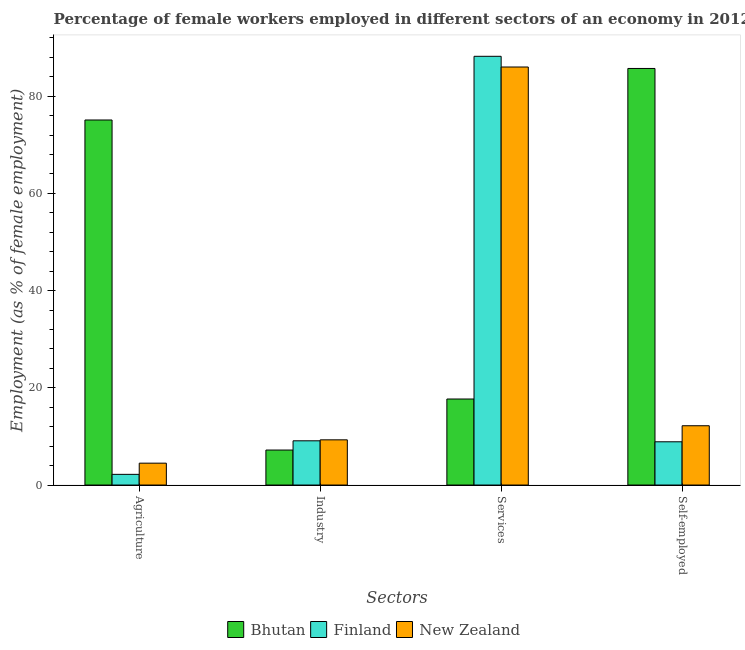How many groups of bars are there?
Your answer should be compact. 4. How many bars are there on the 3rd tick from the left?
Make the answer very short. 3. What is the label of the 3rd group of bars from the left?
Your response must be concise. Services. What is the percentage of female workers in services in Bhutan?
Offer a terse response. 17.7. Across all countries, what is the maximum percentage of female workers in industry?
Keep it short and to the point. 9.3. Across all countries, what is the minimum percentage of female workers in agriculture?
Make the answer very short. 2.2. In which country was the percentage of female workers in agriculture minimum?
Offer a terse response. Finland. What is the total percentage of self employed female workers in the graph?
Offer a terse response. 106.8. What is the difference between the percentage of self employed female workers in Bhutan and that in Finland?
Your answer should be very brief. 76.8. What is the difference between the percentage of female workers in services in Finland and the percentage of female workers in industry in Bhutan?
Give a very brief answer. 81. What is the average percentage of female workers in services per country?
Keep it short and to the point. 63.97. What is the difference between the percentage of female workers in services and percentage of female workers in industry in New Zealand?
Ensure brevity in your answer.  76.7. In how many countries, is the percentage of female workers in agriculture greater than 40 %?
Your answer should be compact. 1. What is the ratio of the percentage of female workers in industry in Finland to that in New Zealand?
Make the answer very short. 0.98. Is the percentage of self employed female workers in Finland less than that in Bhutan?
Provide a short and direct response. Yes. What is the difference between the highest and the second highest percentage of female workers in agriculture?
Your response must be concise. 70.6. What is the difference between the highest and the lowest percentage of self employed female workers?
Your answer should be compact. 76.8. In how many countries, is the percentage of self employed female workers greater than the average percentage of self employed female workers taken over all countries?
Provide a short and direct response. 1. What does the 2nd bar from the right in Agriculture represents?
Ensure brevity in your answer.  Finland. Are the values on the major ticks of Y-axis written in scientific E-notation?
Provide a succinct answer. No. Does the graph contain grids?
Your answer should be compact. No. How are the legend labels stacked?
Your answer should be very brief. Horizontal. What is the title of the graph?
Give a very brief answer. Percentage of female workers employed in different sectors of an economy in 2012. Does "Bulgaria" appear as one of the legend labels in the graph?
Your response must be concise. No. What is the label or title of the X-axis?
Provide a short and direct response. Sectors. What is the label or title of the Y-axis?
Your answer should be compact. Employment (as % of female employment). What is the Employment (as % of female employment) in Bhutan in Agriculture?
Make the answer very short. 75.1. What is the Employment (as % of female employment) of Finland in Agriculture?
Your answer should be compact. 2.2. What is the Employment (as % of female employment) of New Zealand in Agriculture?
Your answer should be very brief. 4.5. What is the Employment (as % of female employment) of Bhutan in Industry?
Offer a very short reply. 7.2. What is the Employment (as % of female employment) in Finland in Industry?
Make the answer very short. 9.1. What is the Employment (as % of female employment) of New Zealand in Industry?
Give a very brief answer. 9.3. What is the Employment (as % of female employment) in Bhutan in Services?
Provide a succinct answer. 17.7. What is the Employment (as % of female employment) of Finland in Services?
Ensure brevity in your answer.  88.2. What is the Employment (as % of female employment) of New Zealand in Services?
Ensure brevity in your answer.  86. What is the Employment (as % of female employment) in Bhutan in Self-employed?
Your response must be concise. 85.7. What is the Employment (as % of female employment) of Finland in Self-employed?
Your answer should be compact. 8.9. What is the Employment (as % of female employment) of New Zealand in Self-employed?
Ensure brevity in your answer.  12.2. Across all Sectors, what is the maximum Employment (as % of female employment) of Bhutan?
Give a very brief answer. 85.7. Across all Sectors, what is the maximum Employment (as % of female employment) of Finland?
Make the answer very short. 88.2. Across all Sectors, what is the minimum Employment (as % of female employment) in Bhutan?
Keep it short and to the point. 7.2. Across all Sectors, what is the minimum Employment (as % of female employment) in Finland?
Provide a short and direct response. 2.2. What is the total Employment (as % of female employment) of Bhutan in the graph?
Ensure brevity in your answer.  185.7. What is the total Employment (as % of female employment) in Finland in the graph?
Ensure brevity in your answer.  108.4. What is the total Employment (as % of female employment) of New Zealand in the graph?
Offer a very short reply. 112. What is the difference between the Employment (as % of female employment) in Bhutan in Agriculture and that in Industry?
Your answer should be very brief. 67.9. What is the difference between the Employment (as % of female employment) in Finland in Agriculture and that in Industry?
Provide a short and direct response. -6.9. What is the difference between the Employment (as % of female employment) in Bhutan in Agriculture and that in Services?
Offer a terse response. 57.4. What is the difference between the Employment (as % of female employment) in Finland in Agriculture and that in Services?
Your answer should be very brief. -86. What is the difference between the Employment (as % of female employment) in New Zealand in Agriculture and that in Services?
Provide a succinct answer. -81.5. What is the difference between the Employment (as % of female employment) of Bhutan in Agriculture and that in Self-employed?
Give a very brief answer. -10.6. What is the difference between the Employment (as % of female employment) of New Zealand in Agriculture and that in Self-employed?
Offer a terse response. -7.7. What is the difference between the Employment (as % of female employment) of Bhutan in Industry and that in Services?
Your response must be concise. -10.5. What is the difference between the Employment (as % of female employment) of Finland in Industry and that in Services?
Offer a terse response. -79.1. What is the difference between the Employment (as % of female employment) in New Zealand in Industry and that in Services?
Your response must be concise. -76.7. What is the difference between the Employment (as % of female employment) of Bhutan in Industry and that in Self-employed?
Provide a short and direct response. -78.5. What is the difference between the Employment (as % of female employment) in Finland in Industry and that in Self-employed?
Offer a very short reply. 0.2. What is the difference between the Employment (as % of female employment) of New Zealand in Industry and that in Self-employed?
Give a very brief answer. -2.9. What is the difference between the Employment (as % of female employment) in Bhutan in Services and that in Self-employed?
Ensure brevity in your answer.  -68. What is the difference between the Employment (as % of female employment) in Finland in Services and that in Self-employed?
Your answer should be very brief. 79.3. What is the difference between the Employment (as % of female employment) of New Zealand in Services and that in Self-employed?
Provide a short and direct response. 73.8. What is the difference between the Employment (as % of female employment) in Bhutan in Agriculture and the Employment (as % of female employment) in Finland in Industry?
Provide a succinct answer. 66. What is the difference between the Employment (as % of female employment) in Bhutan in Agriculture and the Employment (as % of female employment) in New Zealand in Industry?
Ensure brevity in your answer.  65.8. What is the difference between the Employment (as % of female employment) of Finland in Agriculture and the Employment (as % of female employment) of New Zealand in Industry?
Offer a very short reply. -7.1. What is the difference between the Employment (as % of female employment) of Bhutan in Agriculture and the Employment (as % of female employment) of Finland in Services?
Give a very brief answer. -13.1. What is the difference between the Employment (as % of female employment) of Finland in Agriculture and the Employment (as % of female employment) of New Zealand in Services?
Your response must be concise. -83.8. What is the difference between the Employment (as % of female employment) in Bhutan in Agriculture and the Employment (as % of female employment) in Finland in Self-employed?
Offer a very short reply. 66.2. What is the difference between the Employment (as % of female employment) in Bhutan in Agriculture and the Employment (as % of female employment) in New Zealand in Self-employed?
Your response must be concise. 62.9. What is the difference between the Employment (as % of female employment) of Finland in Agriculture and the Employment (as % of female employment) of New Zealand in Self-employed?
Keep it short and to the point. -10. What is the difference between the Employment (as % of female employment) of Bhutan in Industry and the Employment (as % of female employment) of Finland in Services?
Ensure brevity in your answer.  -81. What is the difference between the Employment (as % of female employment) in Bhutan in Industry and the Employment (as % of female employment) in New Zealand in Services?
Make the answer very short. -78.8. What is the difference between the Employment (as % of female employment) of Finland in Industry and the Employment (as % of female employment) of New Zealand in Services?
Offer a terse response. -76.9. What is the difference between the Employment (as % of female employment) in Finland in Industry and the Employment (as % of female employment) in New Zealand in Self-employed?
Make the answer very short. -3.1. What is the difference between the Employment (as % of female employment) of Bhutan in Services and the Employment (as % of female employment) of Finland in Self-employed?
Your response must be concise. 8.8. What is the average Employment (as % of female employment) in Bhutan per Sectors?
Provide a short and direct response. 46.42. What is the average Employment (as % of female employment) of Finland per Sectors?
Keep it short and to the point. 27.1. What is the difference between the Employment (as % of female employment) of Bhutan and Employment (as % of female employment) of Finland in Agriculture?
Your answer should be compact. 72.9. What is the difference between the Employment (as % of female employment) of Bhutan and Employment (as % of female employment) of New Zealand in Agriculture?
Your answer should be compact. 70.6. What is the difference between the Employment (as % of female employment) in Finland and Employment (as % of female employment) in New Zealand in Agriculture?
Your answer should be very brief. -2.3. What is the difference between the Employment (as % of female employment) of Bhutan and Employment (as % of female employment) of New Zealand in Industry?
Keep it short and to the point. -2.1. What is the difference between the Employment (as % of female employment) of Finland and Employment (as % of female employment) of New Zealand in Industry?
Offer a terse response. -0.2. What is the difference between the Employment (as % of female employment) in Bhutan and Employment (as % of female employment) in Finland in Services?
Offer a very short reply. -70.5. What is the difference between the Employment (as % of female employment) in Bhutan and Employment (as % of female employment) in New Zealand in Services?
Provide a succinct answer. -68.3. What is the difference between the Employment (as % of female employment) of Finland and Employment (as % of female employment) of New Zealand in Services?
Ensure brevity in your answer.  2.2. What is the difference between the Employment (as % of female employment) in Bhutan and Employment (as % of female employment) in Finland in Self-employed?
Your answer should be compact. 76.8. What is the difference between the Employment (as % of female employment) in Bhutan and Employment (as % of female employment) in New Zealand in Self-employed?
Make the answer very short. 73.5. What is the difference between the Employment (as % of female employment) in Finland and Employment (as % of female employment) in New Zealand in Self-employed?
Your answer should be compact. -3.3. What is the ratio of the Employment (as % of female employment) of Bhutan in Agriculture to that in Industry?
Make the answer very short. 10.43. What is the ratio of the Employment (as % of female employment) of Finland in Agriculture to that in Industry?
Your answer should be compact. 0.24. What is the ratio of the Employment (as % of female employment) in New Zealand in Agriculture to that in Industry?
Your response must be concise. 0.48. What is the ratio of the Employment (as % of female employment) of Bhutan in Agriculture to that in Services?
Ensure brevity in your answer.  4.24. What is the ratio of the Employment (as % of female employment) in Finland in Agriculture to that in Services?
Make the answer very short. 0.02. What is the ratio of the Employment (as % of female employment) in New Zealand in Agriculture to that in Services?
Offer a terse response. 0.05. What is the ratio of the Employment (as % of female employment) of Bhutan in Agriculture to that in Self-employed?
Provide a succinct answer. 0.88. What is the ratio of the Employment (as % of female employment) of Finland in Agriculture to that in Self-employed?
Offer a terse response. 0.25. What is the ratio of the Employment (as % of female employment) in New Zealand in Agriculture to that in Self-employed?
Give a very brief answer. 0.37. What is the ratio of the Employment (as % of female employment) of Bhutan in Industry to that in Services?
Give a very brief answer. 0.41. What is the ratio of the Employment (as % of female employment) of Finland in Industry to that in Services?
Keep it short and to the point. 0.1. What is the ratio of the Employment (as % of female employment) in New Zealand in Industry to that in Services?
Your answer should be very brief. 0.11. What is the ratio of the Employment (as % of female employment) in Bhutan in Industry to that in Self-employed?
Provide a short and direct response. 0.08. What is the ratio of the Employment (as % of female employment) of Finland in Industry to that in Self-employed?
Your response must be concise. 1.02. What is the ratio of the Employment (as % of female employment) in New Zealand in Industry to that in Self-employed?
Provide a succinct answer. 0.76. What is the ratio of the Employment (as % of female employment) in Bhutan in Services to that in Self-employed?
Ensure brevity in your answer.  0.21. What is the ratio of the Employment (as % of female employment) of Finland in Services to that in Self-employed?
Ensure brevity in your answer.  9.91. What is the ratio of the Employment (as % of female employment) in New Zealand in Services to that in Self-employed?
Offer a terse response. 7.05. What is the difference between the highest and the second highest Employment (as % of female employment) in Bhutan?
Offer a very short reply. 10.6. What is the difference between the highest and the second highest Employment (as % of female employment) in Finland?
Give a very brief answer. 79.1. What is the difference between the highest and the second highest Employment (as % of female employment) in New Zealand?
Offer a very short reply. 73.8. What is the difference between the highest and the lowest Employment (as % of female employment) of Bhutan?
Provide a short and direct response. 78.5. What is the difference between the highest and the lowest Employment (as % of female employment) in Finland?
Make the answer very short. 86. What is the difference between the highest and the lowest Employment (as % of female employment) in New Zealand?
Your response must be concise. 81.5. 